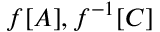Convert formula to latex. <formula><loc_0><loc_0><loc_500><loc_500>f [ A ] , f ^ { - 1 } [ C ]</formula> 